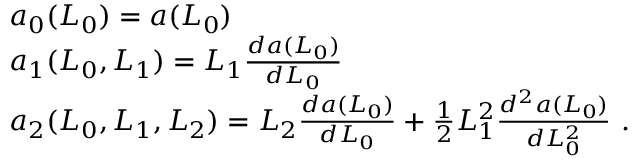Convert formula to latex. <formula><loc_0><loc_0><loc_500><loc_500>\begin{array} { r l } & { a _ { 0 } ( L _ { 0 } ) = a ( L _ { 0 } ) } \\ & { a _ { 1 } ( L _ { 0 } , L _ { 1 } ) = L _ { 1 } \frac { d a ( L _ { 0 } ) } { d L _ { 0 } } } \\ & { a _ { 2 } ( L _ { 0 } , L _ { 1 } , L _ { 2 } ) = L _ { 2 } \frac { d a ( L _ { 0 } ) } { d L _ { 0 } } + \frac { 1 } { 2 } L _ { 1 } ^ { 2 } \frac { d ^ { 2 } a ( L _ { 0 } ) } { d L _ { 0 } ^ { 2 } } \ . } \end{array}</formula> 